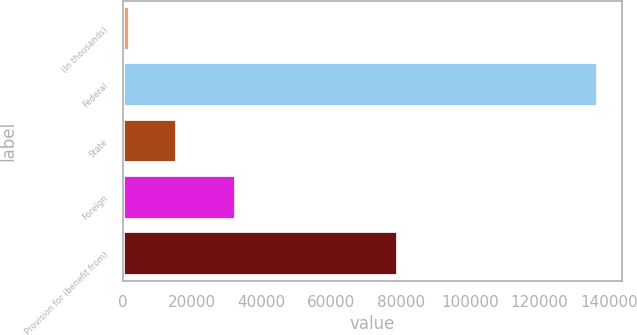Convert chart. <chart><loc_0><loc_0><loc_500><loc_500><bar_chart><fcel>(In thousands)<fcel>Federal<fcel>State<fcel>Foreign<fcel>Provision for (benefit from)<nl><fcel>2009<fcel>136906<fcel>15498.7<fcel>32647<fcel>79163<nl></chart> 